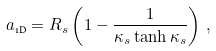<formula> <loc_0><loc_0><loc_500><loc_500>a _ { \text {1D} } = R _ { s } \left ( 1 - \frac { 1 } { \kappa _ { s } \tanh \kappa _ { s } } \right ) \, ,</formula> 